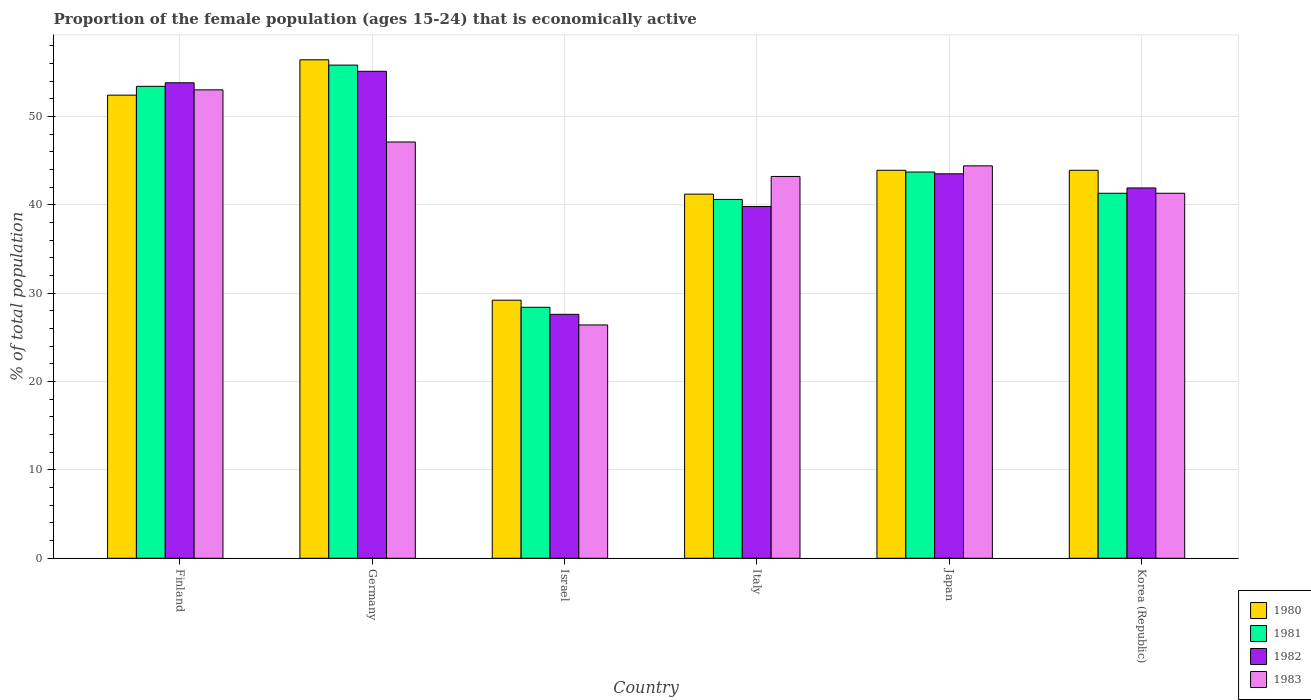How many different coloured bars are there?
Your answer should be very brief. 4. How many groups of bars are there?
Offer a very short reply. 6. How many bars are there on the 5th tick from the left?
Your response must be concise. 4. How many bars are there on the 3rd tick from the right?
Make the answer very short. 4. In how many cases, is the number of bars for a given country not equal to the number of legend labels?
Make the answer very short. 0. What is the proportion of the female population that is economically active in 1982 in Korea (Republic)?
Your response must be concise. 41.9. Across all countries, what is the maximum proportion of the female population that is economically active in 1982?
Your answer should be compact. 55.1. Across all countries, what is the minimum proportion of the female population that is economically active in 1983?
Your answer should be compact. 26.4. In which country was the proportion of the female population that is economically active in 1982 maximum?
Offer a terse response. Germany. What is the total proportion of the female population that is economically active in 1980 in the graph?
Provide a succinct answer. 267. What is the difference between the proportion of the female population that is economically active in 1981 in Finland and that in Japan?
Provide a succinct answer. 9.7. What is the difference between the proportion of the female population that is economically active in 1981 in Korea (Republic) and the proportion of the female population that is economically active in 1983 in Italy?
Make the answer very short. -1.9. What is the average proportion of the female population that is economically active in 1980 per country?
Provide a short and direct response. 44.5. What is the difference between the proportion of the female population that is economically active of/in 1982 and proportion of the female population that is economically active of/in 1983 in Japan?
Keep it short and to the point. -0.9. In how many countries, is the proportion of the female population that is economically active in 1983 greater than 54 %?
Provide a short and direct response. 0. What is the ratio of the proportion of the female population that is economically active in 1982 in Finland to that in Japan?
Keep it short and to the point. 1.24. Is the difference between the proportion of the female population that is economically active in 1982 in Germany and Israel greater than the difference between the proportion of the female population that is economically active in 1983 in Germany and Israel?
Offer a terse response. Yes. What is the difference between the highest and the second highest proportion of the female population that is economically active in 1983?
Provide a succinct answer. -8.6. What is the difference between the highest and the lowest proportion of the female population that is economically active in 1983?
Provide a short and direct response. 26.6. Is the sum of the proportion of the female population that is economically active in 1983 in Israel and Japan greater than the maximum proportion of the female population that is economically active in 1980 across all countries?
Your response must be concise. Yes. Is it the case that in every country, the sum of the proportion of the female population that is economically active in 1982 and proportion of the female population that is economically active in 1981 is greater than the proportion of the female population that is economically active in 1983?
Offer a very short reply. Yes. Are the values on the major ticks of Y-axis written in scientific E-notation?
Provide a short and direct response. No. Does the graph contain any zero values?
Keep it short and to the point. No. Does the graph contain grids?
Keep it short and to the point. Yes. Where does the legend appear in the graph?
Provide a short and direct response. Bottom right. How are the legend labels stacked?
Your response must be concise. Vertical. What is the title of the graph?
Make the answer very short. Proportion of the female population (ages 15-24) that is economically active. Does "1996" appear as one of the legend labels in the graph?
Offer a terse response. No. What is the label or title of the X-axis?
Your answer should be very brief. Country. What is the label or title of the Y-axis?
Your response must be concise. % of total population. What is the % of total population in 1980 in Finland?
Keep it short and to the point. 52.4. What is the % of total population of 1981 in Finland?
Make the answer very short. 53.4. What is the % of total population in 1982 in Finland?
Your response must be concise. 53.8. What is the % of total population in 1983 in Finland?
Ensure brevity in your answer.  53. What is the % of total population of 1980 in Germany?
Your response must be concise. 56.4. What is the % of total population of 1981 in Germany?
Provide a short and direct response. 55.8. What is the % of total population in 1982 in Germany?
Provide a short and direct response. 55.1. What is the % of total population of 1983 in Germany?
Your answer should be compact. 47.1. What is the % of total population in 1980 in Israel?
Your answer should be compact. 29.2. What is the % of total population of 1981 in Israel?
Make the answer very short. 28.4. What is the % of total population of 1982 in Israel?
Your answer should be compact. 27.6. What is the % of total population of 1983 in Israel?
Your answer should be very brief. 26.4. What is the % of total population in 1980 in Italy?
Ensure brevity in your answer.  41.2. What is the % of total population in 1981 in Italy?
Offer a terse response. 40.6. What is the % of total population of 1982 in Italy?
Offer a very short reply. 39.8. What is the % of total population of 1983 in Italy?
Keep it short and to the point. 43.2. What is the % of total population of 1980 in Japan?
Keep it short and to the point. 43.9. What is the % of total population of 1981 in Japan?
Ensure brevity in your answer.  43.7. What is the % of total population of 1982 in Japan?
Ensure brevity in your answer.  43.5. What is the % of total population of 1983 in Japan?
Ensure brevity in your answer.  44.4. What is the % of total population of 1980 in Korea (Republic)?
Make the answer very short. 43.9. What is the % of total population in 1981 in Korea (Republic)?
Provide a short and direct response. 41.3. What is the % of total population in 1982 in Korea (Republic)?
Ensure brevity in your answer.  41.9. What is the % of total population in 1983 in Korea (Republic)?
Make the answer very short. 41.3. Across all countries, what is the maximum % of total population in 1980?
Your response must be concise. 56.4. Across all countries, what is the maximum % of total population of 1981?
Give a very brief answer. 55.8. Across all countries, what is the maximum % of total population in 1982?
Provide a succinct answer. 55.1. Across all countries, what is the maximum % of total population of 1983?
Your answer should be compact. 53. Across all countries, what is the minimum % of total population in 1980?
Offer a very short reply. 29.2. Across all countries, what is the minimum % of total population in 1981?
Your answer should be very brief. 28.4. Across all countries, what is the minimum % of total population in 1982?
Offer a terse response. 27.6. Across all countries, what is the minimum % of total population of 1983?
Your answer should be compact. 26.4. What is the total % of total population of 1980 in the graph?
Offer a very short reply. 267. What is the total % of total population of 1981 in the graph?
Provide a succinct answer. 263.2. What is the total % of total population in 1982 in the graph?
Make the answer very short. 261.7. What is the total % of total population of 1983 in the graph?
Provide a short and direct response. 255.4. What is the difference between the % of total population in 1981 in Finland and that in Germany?
Offer a very short reply. -2.4. What is the difference between the % of total population in 1982 in Finland and that in Germany?
Your response must be concise. -1.3. What is the difference between the % of total population in 1980 in Finland and that in Israel?
Make the answer very short. 23.2. What is the difference between the % of total population of 1981 in Finland and that in Israel?
Keep it short and to the point. 25. What is the difference between the % of total population of 1982 in Finland and that in Israel?
Your answer should be very brief. 26.2. What is the difference between the % of total population of 1983 in Finland and that in Israel?
Keep it short and to the point. 26.6. What is the difference between the % of total population of 1981 in Finland and that in Italy?
Provide a succinct answer. 12.8. What is the difference between the % of total population of 1980 in Finland and that in Japan?
Provide a succinct answer. 8.5. What is the difference between the % of total population in 1982 in Finland and that in Japan?
Your answer should be very brief. 10.3. What is the difference between the % of total population in 1980 in Finland and that in Korea (Republic)?
Your response must be concise. 8.5. What is the difference between the % of total population in 1981 in Finland and that in Korea (Republic)?
Your answer should be compact. 12.1. What is the difference between the % of total population of 1983 in Finland and that in Korea (Republic)?
Your response must be concise. 11.7. What is the difference between the % of total population in 1980 in Germany and that in Israel?
Provide a short and direct response. 27.2. What is the difference between the % of total population of 1981 in Germany and that in Israel?
Your response must be concise. 27.4. What is the difference between the % of total population of 1983 in Germany and that in Israel?
Provide a short and direct response. 20.7. What is the difference between the % of total population of 1980 in Germany and that in Italy?
Your response must be concise. 15.2. What is the difference between the % of total population of 1982 in Germany and that in Italy?
Offer a very short reply. 15.3. What is the difference between the % of total population in 1983 in Germany and that in Italy?
Make the answer very short. 3.9. What is the difference between the % of total population of 1981 in Germany and that in Japan?
Offer a very short reply. 12.1. What is the difference between the % of total population in 1982 in Germany and that in Japan?
Ensure brevity in your answer.  11.6. What is the difference between the % of total population in 1980 in Germany and that in Korea (Republic)?
Provide a short and direct response. 12.5. What is the difference between the % of total population of 1982 in Germany and that in Korea (Republic)?
Provide a short and direct response. 13.2. What is the difference between the % of total population of 1983 in Germany and that in Korea (Republic)?
Offer a very short reply. 5.8. What is the difference between the % of total population of 1980 in Israel and that in Italy?
Provide a short and direct response. -12. What is the difference between the % of total population of 1983 in Israel and that in Italy?
Offer a very short reply. -16.8. What is the difference between the % of total population in 1980 in Israel and that in Japan?
Make the answer very short. -14.7. What is the difference between the % of total population of 1981 in Israel and that in Japan?
Your answer should be very brief. -15.3. What is the difference between the % of total population of 1982 in Israel and that in Japan?
Give a very brief answer. -15.9. What is the difference between the % of total population in 1980 in Israel and that in Korea (Republic)?
Your response must be concise. -14.7. What is the difference between the % of total population of 1982 in Israel and that in Korea (Republic)?
Offer a very short reply. -14.3. What is the difference between the % of total population of 1983 in Israel and that in Korea (Republic)?
Keep it short and to the point. -14.9. What is the difference between the % of total population of 1981 in Italy and that in Japan?
Your answer should be compact. -3.1. What is the difference between the % of total population in 1983 in Italy and that in Japan?
Make the answer very short. -1.2. What is the difference between the % of total population of 1980 in Italy and that in Korea (Republic)?
Provide a short and direct response. -2.7. What is the difference between the % of total population of 1981 in Italy and that in Korea (Republic)?
Ensure brevity in your answer.  -0.7. What is the difference between the % of total population of 1982 in Italy and that in Korea (Republic)?
Provide a short and direct response. -2.1. What is the difference between the % of total population in 1981 in Finland and the % of total population in 1982 in Germany?
Make the answer very short. -1.7. What is the difference between the % of total population of 1980 in Finland and the % of total population of 1981 in Israel?
Offer a terse response. 24. What is the difference between the % of total population of 1980 in Finland and the % of total population of 1982 in Israel?
Provide a succinct answer. 24.8. What is the difference between the % of total population in 1980 in Finland and the % of total population in 1983 in Israel?
Provide a short and direct response. 26. What is the difference between the % of total population in 1981 in Finland and the % of total population in 1982 in Israel?
Make the answer very short. 25.8. What is the difference between the % of total population of 1981 in Finland and the % of total population of 1983 in Israel?
Your answer should be compact. 27. What is the difference between the % of total population in 1982 in Finland and the % of total population in 1983 in Israel?
Your answer should be compact. 27.4. What is the difference between the % of total population of 1980 in Finland and the % of total population of 1981 in Italy?
Offer a terse response. 11.8. What is the difference between the % of total population of 1980 in Finland and the % of total population of 1982 in Italy?
Provide a succinct answer. 12.6. What is the difference between the % of total population of 1980 in Finland and the % of total population of 1981 in Japan?
Provide a short and direct response. 8.7. What is the difference between the % of total population in 1980 in Finland and the % of total population in 1983 in Japan?
Keep it short and to the point. 8. What is the difference between the % of total population of 1981 in Finland and the % of total population of 1982 in Japan?
Give a very brief answer. 9.9. What is the difference between the % of total population of 1982 in Finland and the % of total population of 1983 in Japan?
Keep it short and to the point. 9.4. What is the difference between the % of total population of 1980 in Finland and the % of total population of 1981 in Korea (Republic)?
Offer a terse response. 11.1. What is the difference between the % of total population of 1980 in Germany and the % of total population of 1981 in Israel?
Offer a very short reply. 28. What is the difference between the % of total population in 1980 in Germany and the % of total population in 1982 in Israel?
Keep it short and to the point. 28.8. What is the difference between the % of total population in 1980 in Germany and the % of total population in 1983 in Israel?
Your answer should be very brief. 30. What is the difference between the % of total population of 1981 in Germany and the % of total population of 1982 in Israel?
Offer a terse response. 28.2. What is the difference between the % of total population in 1981 in Germany and the % of total population in 1983 in Israel?
Your answer should be compact. 29.4. What is the difference between the % of total population in 1982 in Germany and the % of total population in 1983 in Israel?
Provide a succinct answer. 28.7. What is the difference between the % of total population in 1980 in Germany and the % of total population in 1983 in Italy?
Make the answer very short. 13.2. What is the difference between the % of total population of 1980 in Germany and the % of total population of 1981 in Japan?
Your answer should be very brief. 12.7. What is the difference between the % of total population of 1980 in Germany and the % of total population of 1982 in Japan?
Your answer should be very brief. 12.9. What is the difference between the % of total population of 1980 in Germany and the % of total population of 1981 in Korea (Republic)?
Your answer should be very brief. 15.1. What is the difference between the % of total population of 1980 in Germany and the % of total population of 1983 in Korea (Republic)?
Provide a short and direct response. 15.1. What is the difference between the % of total population in 1982 in Germany and the % of total population in 1983 in Korea (Republic)?
Provide a succinct answer. 13.8. What is the difference between the % of total population of 1980 in Israel and the % of total population of 1982 in Italy?
Your response must be concise. -10.6. What is the difference between the % of total population in 1980 in Israel and the % of total population in 1983 in Italy?
Your response must be concise. -14. What is the difference between the % of total population of 1981 in Israel and the % of total population of 1982 in Italy?
Offer a terse response. -11.4. What is the difference between the % of total population of 1981 in Israel and the % of total population of 1983 in Italy?
Your answer should be very brief. -14.8. What is the difference between the % of total population in 1982 in Israel and the % of total population in 1983 in Italy?
Your response must be concise. -15.6. What is the difference between the % of total population of 1980 in Israel and the % of total population of 1981 in Japan?
Offer a terse response. -14.5. What is the difference between the % of total population of 1980 in Israel and the % of total population of 1982 in Japan?
Keep it short and to the point. -14.3. What is the difference between the % of total population of 1980 in Israel and the % of total population of 1983 in Japan?
Your answer should be very brief. -15.2. What is the difference between the % of total population of 1981 in Israel and the % of total population of 1982 in Japan?
Your response must be concise. -15.1. What is the difference between the % of total population of 1982 in Israel and the % of total population of 1983 in Japan?
Your response must be concise. -16.8. What is the difference between the % of total population of 1980 in Israel and the % of total population of 1981 in Korea (Republic)?
Ensure brevity in your answer.  -12.1. What is the difference between the % of total population in 1980 in Israel and the % of total population in 1982 in Korea (Republic)?
Offer a terse response. -12.7. What is the difference between the % of total population in 1980 in Israel and the % of total population in 1983 in Korea (Republic)?
Provide a succinct answer. -12.1. What is the difference between the % of total population of 1981 in Israel and the % of total population of 1983 in Korea (Republic)?
Make the answer very short. -12.9. What is the difference between the % of total population of 1982 in Israel and the % of total population of 1983 in Korea (Republic)?
Your answer should be compact. -13.7. What is the difference between the % of total population of 1980 in Italy and the % of total population of 1981 in Japan?
Provide a succinct answer. -2.5. What is the difference between the % of total population of 1980 in Italy and the % of total population of 1982 in Japan?
Provide a short and direct response. -2.3. What is the difference between the % of total population in 1981 in Italy and the % of total population in 1983 in Japan?
Your answer should be compact. -3.8. What is the difference between the % of total population in 1980 in Italy and the % of total population in 1982 in Korea (Republic)?
Give a very brief answer. -0.7. What is the difference between the % of total population in 1980 in Japan and the % of total population in 1981 in Korea (Republic)?
Your response must be concise. 2.6. What is the difference between the % of total population of 1981 in Japan and the % of total population of 1983 in Korea (Republic)?
Keep it short and to the point. 2.4. What is the difference between the % of total population in 1982 in Japan and the % of total population in 1983 in Korea (Republic)?
Keep it short and to the point. 2.2. What is the average % of total population in 1980 per country?
Provide a short and direct response. 44.5. What is the average % of total population of 1981 per country?
Ensure brevity in your answer.  43.87. What is the average % of total population of 1982 per country?
Your answer should be very brief. 43.62. What is the average % of total population in 1983 per country?
Give a very brief answer. 42.57. What is the difference between the % of total population of 1980 and % of total population of 1983 in Finland?
Your answer should be very brief. -0.6. What is the difference between the % of total population in 1981 and % of total population in 1982 in Finland?
Provide a succinct answer. -0.4. What is the difference between the % of total population in 1982 and % of total population in 1983 in Finland?
Your answer should be very brief. 0.8. What is the difference between the % of total population of 1980 and % of total population of 1982 in Germany?
Keep it short and to the point. 1.3. What is the difference between the % of total population in 1980 and % of total population in 1983 in Germany?
Your response must be concise. 9.3. What is the difference between the % of total population in 1981 and % of total population in 1983 in Germany?
Keep it short and to the point. 8.7. What is the difference between the % of total population in 1982 and % of total population in 1983 in Germany?
Give a very brief answer. 8. What is the difference between the % of total population in 1980 and % of total population in 1982 in Israel?
Offer a terse response. 1.6. What is the difference between the % of total population in 1981 and % of total population in 1983 in Israel?
Provide a succinct answer. 2. What is the difference between the % of total population in 1982 and % of total population in 1983 in Israel?
Make the answer very short. 1.2. What is the difference between the % of total population of 1980 and % of total population of 1982 in Italy?
Keep it short and to the point. 1.4. What is the difference between the % of total population in 1980 and % of total population in 1983 in Italy?
Your answer should be compact. -2. What is the difference between the % of total population in 1981 and % of total population in 1982 in Italy?
Provide a short and direct response. 0.8. What is the difference between the % of total population in 1982 and % of total population in 1983 in Italy?
Make the answer very short. -3.4. What is the difference between the % of total population in 1980 and % of total population in 1981 in Japan?
Keep it short and to the point. 0.2. What is the difference between the % of total population in 1980 and % of total population in 1982 in Japan?
Ensure brevity in your answer.  0.4. What is the difference between the % of total population in 1980 and % of total population in 1983 in Japan?
Make the answer very short. -0.5. What is the difference between the % of total population of 1981 and % of total population of 1983 in Japan?
Your answer should be compact. -0.7. What is the difference between the % of total population of 1982 and % of total population of 1983 in Japan?
Offer a very short reply. -0.9. What is the difference between the % of total population of 1980 and % of total population of 1981 in Korea (Republic)?
Make the answer very short. 2.6. What is the difference between the % of total population in 1981 and % of total population in 1982 in Korea (Republic)?
Your answer should be very brief. -0.6. What is the ratio of the % of total population of 1980 in Finland to that in Germany?
Offer a terse response. 0.93. What is the ratio of the % of total population in 1981 in Finland to that in Germany?
Make the answer very short. 0.96. What is the ratio of the % of total population of 1982 in Finland to that in Germany?
Offer a terse response. 0.98. What is the ratio of the % of total population in 1983 in Finland to that in Germany?
Your response must be concise. 1.13. What is the ratio of the % of total population of 1980 in Finland to that in Israel?
Give a very brief answer. 1.79. What is the ratio of the % of total population of 1981 in Finland to that in Israel?
Keep it short and to the point. 1.88. What is the ratio of the % of total population in 1982 in Finland to that in Israel?
Give a very brief answer. 1.95. What is the ratio of the % of total population in 1983 in Finland to that in Israel?
Provide a succinct answer. 2.01. What is the ratio of the % of total population in 1980 in Finland to that in Italy?
Your answer should be compact. 1.27. What is the ratio of the % of total population in 1981 in Finland to that in Italy?
Keep it short and to the point. 1.32. What is the ratio of the % of total population in 1982 in Finland to that in Italy?
Ensure brevity in your answer.  1.35. What is the ratio of the % of total population in 1983 in Finland to that in Italy?
Give a very brief answer. 1.23. What is the ratio of the % of total population in 1980 in Finland to that in Japan?
Make the answer very short. 1.19. What is the ratio of the % of total population of 1981 in Finland to that in Japan?
Your answer should be compact. 1.22. What is the ratio of the % of total population of 1982 in Finland to that in Japan?
Keep it short and to the point. 1.24. What is the ratio of the % of total population of 1983 in Finland to that in Japan?
Give a very brief answer. 1.19. What is the ratio of the % of total population in 1980 in Finland to that in Korea (Republic)?
Give a very brief answer. 1.19. What is the ratio of the % of total population in 1981 in Finland to that in Korea (Republic)?
Give a very brief answer. 1.29. What is the ratio of the % of total population in 1982 in Finland to that in Korea (Republic)?
Provide a succinct answer. 1.28. What is the ratio of the % of total population of 1983 in Finland to that in Korea (Republic)?
Your answer should be very brief. 1.28. What is the ratio of the % of total population in 1980 in Germany to that in Israel?
Your answer should be compact. 1.93. What is the ratio of the % of total population of 1981 in Germany to that in Israel?
Ensure brevity in your answer.  1.96. What is the ratio of the % of total population of 1982 in Germany to that in Israel?
Give a very brief answer. 2. What is the ratio of the % of total population in 1983 in Germany to that in Israel?
Offer a terse response. 1.78. What is the ratio of the % of total population of 1980 in Germany to that in Italy?
Make the answer very short. 1.37. What is the ratio of the % of total population of 1981 in Germany to that in Italy?
Make the answer very short. 1.37. What is the ratio of the % of total population of 1982 in Germany to that in Italy?
Provide a short and direct response. 1.38. What is the ratio of the % of total population of 1983 in Germany to that in Italy?
Your response must be concise. 1.09. What is the ratio of the % of total population in 1980 in Germany to that in Japan?
Provide a succinct answer. 1.28. What is the ratio of the % of total population of 1981 in Germany to that in Japan?
Make the answer very short. 1.28. What is the ratio of the % of total population of 1982 in Germany to that in Japan?
Your answer should be compact. 1.27. What is the ratio of the % of total population in 1983 in Germany to that in Japan?
Offer a very short reply. 1.06. What is the ratio of the % of total population of 1980 in Germany to that in Korea (Republic)?
Your answer should be very brief. 1.28. What is the ratio of the % of total population in 1981 in Germany to that in Korea (Republic)?
Ensure brevity in your answer.  1.35. What is the ratio of the % of total population in 1982 in Germany to that in Korea (Republic)?
Make the answer very short. 1.31. What is the ratio of the % of total population of 1983 in Germany to that in Korea (Republic)?
Give a very brief answer. 1.14. What is the ratio of the % of total population of 1980 in Israel to that in Italy?
Provide a short and direct response. 0.71. What is the ratio of the % of total population of 1981 in Israel to that in Italy?
Keep it short and to the point. 0.7. What is the ratio of the % of total population in 1982 in Israel to that in Italy?
Make the answer very short. 0.69. What is the ratio of the % of total population of 1983 in Israel to that in Italy?
Your answer should be very brief. 0.61. What is the ratio of the % of total population of 1980 in Israel to that in Japan?
Give a very brief answer. 0.67. What is the ratio of the % of total population of 1981 in Israel to that in Japan?
Provide a short and direct response. 0.65. What is the ratio of the % of total population of 1982 in Israel to that in Japan?
Make the answer very short. 0.63. What is the ratio of the % of total population in 1983 in Israel to that in Japan?
Your answer should be compact. 0.59. What is the ratio of the % of total population of 1980 in Israel to that in Korea (Republic)?
Ensure brevity in your answer.  0.67. What is the ratio of the % of total population in 1981 in Israel to that in Korea (Republic)?
Provide a succinct answer. 0.69. What is the ratio of the % of total population of 1982 in Israel to that in Korea (Republic)?
Provide a short and direct response. 0.66. What is the ratio of the % of total population of 1983 in Israel to that in Korea (Republic)?
Provide a succinct answer. 0.64. What is the ratio of the % of total population of 1980 in Italy to that in Japan?
Provide a short and direct response. 0.94. What is the ratio of the % of total population in 1981 in Italy to that in Japan?
Your answer should be very brief. 0.93. What is the ratio of the % of total population of 1982 in Italy to that in Japan?
Provide a succinct answer. 0.91. What is the ratio of the % of total population in 1980 in Italy to that in Korea (Republic)?
Provide a short and direct response. 0.94. What is the ratio of the % of total population in 1981 in Italy to that in Korea (Republic)?
Provide a short and direct response. 0.98. What is the ratio of the % of total population in 1982 in Italy to that in Korea (Republic)?
Give a very brief answer. 0.95. What is the ratio of the % of total population in 1983 in Italy to that in Korea (Republic)?
Make the answer very short. 1.05. What is the ratio of the % of total population in 1981 in Japan to that in Korea (Republic)?
Provide a short and direct response. 1.06. What is the ratio of the % of total population of 1982 in Japan to that in Korea (Republic)?
Give a very brief answer. 1.04. What is the ratio of the % of total population in 1983 in Japan to that in Korea (Republic)?
Offer a very short reply. 1.08. What is the difference between the highest and the second highest % of total population in 1983?
Provide a succinct answer. 5.9. What is the difference between the highest and the lowest % of total population in 1980?
Provide a succinct answer. 27.2. What is the difference between the highest and the lowest % of total population in 1981?
Your answer should be very brief. 27.4. What is the difference between the highest and the lowest % of total population of 1982?
Provide a succinct answer. 27.5. What is the difference between the highest and the lowest % of total population in 1983?
Ensure brevity in your answer.  26.6. 